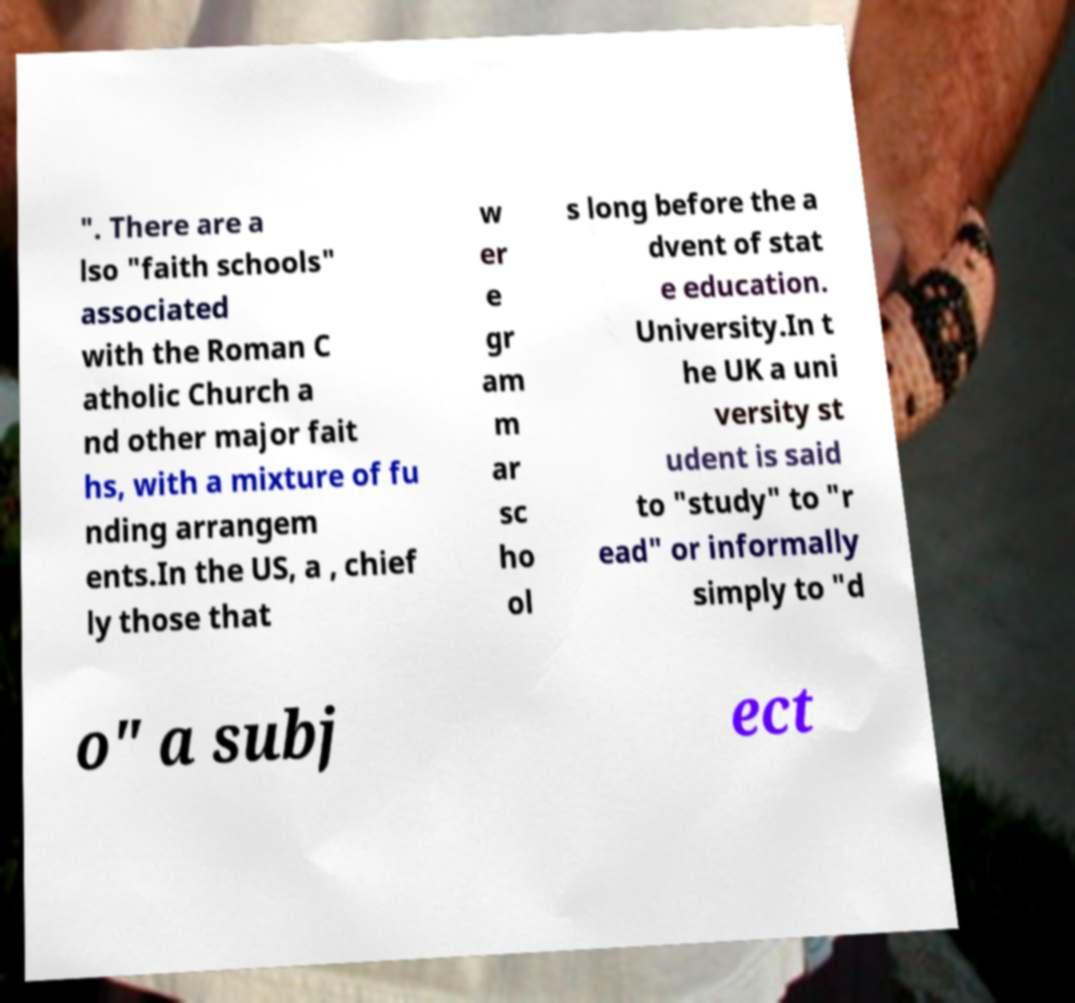Can you accurately transcribe the text from the provided image for me? ". There are a lso "faith schools" associated with the Roman C atholic Church a nd other major fait hs, with a mixture of fu nding arrangem ents.In the US, a , chief ly those that w er e gr am m ar sc ho ol s long before the a dvent of stat e education. University.In t he UK a uni versity st udent is said to "study" to "r ead" or informally simply to "d o" a subj ect 